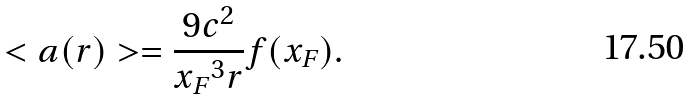<formula> <loc_0><loc_0><loc_500><loc_500>< a ( r ) > = \frac { 9 c ^ { 2 } } { { x _ { F } } ^ { 3 } r } f ( x _ { F } ) .</formula> 